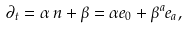Convert formula to latex. <formula><loc_0><loc_0><loc_500><loc_500>\partial _ { t } = \alpha \, n + \beta = \alpha e _ { 0 } + \beta ^ { a } e _ { a } ,</formula> 